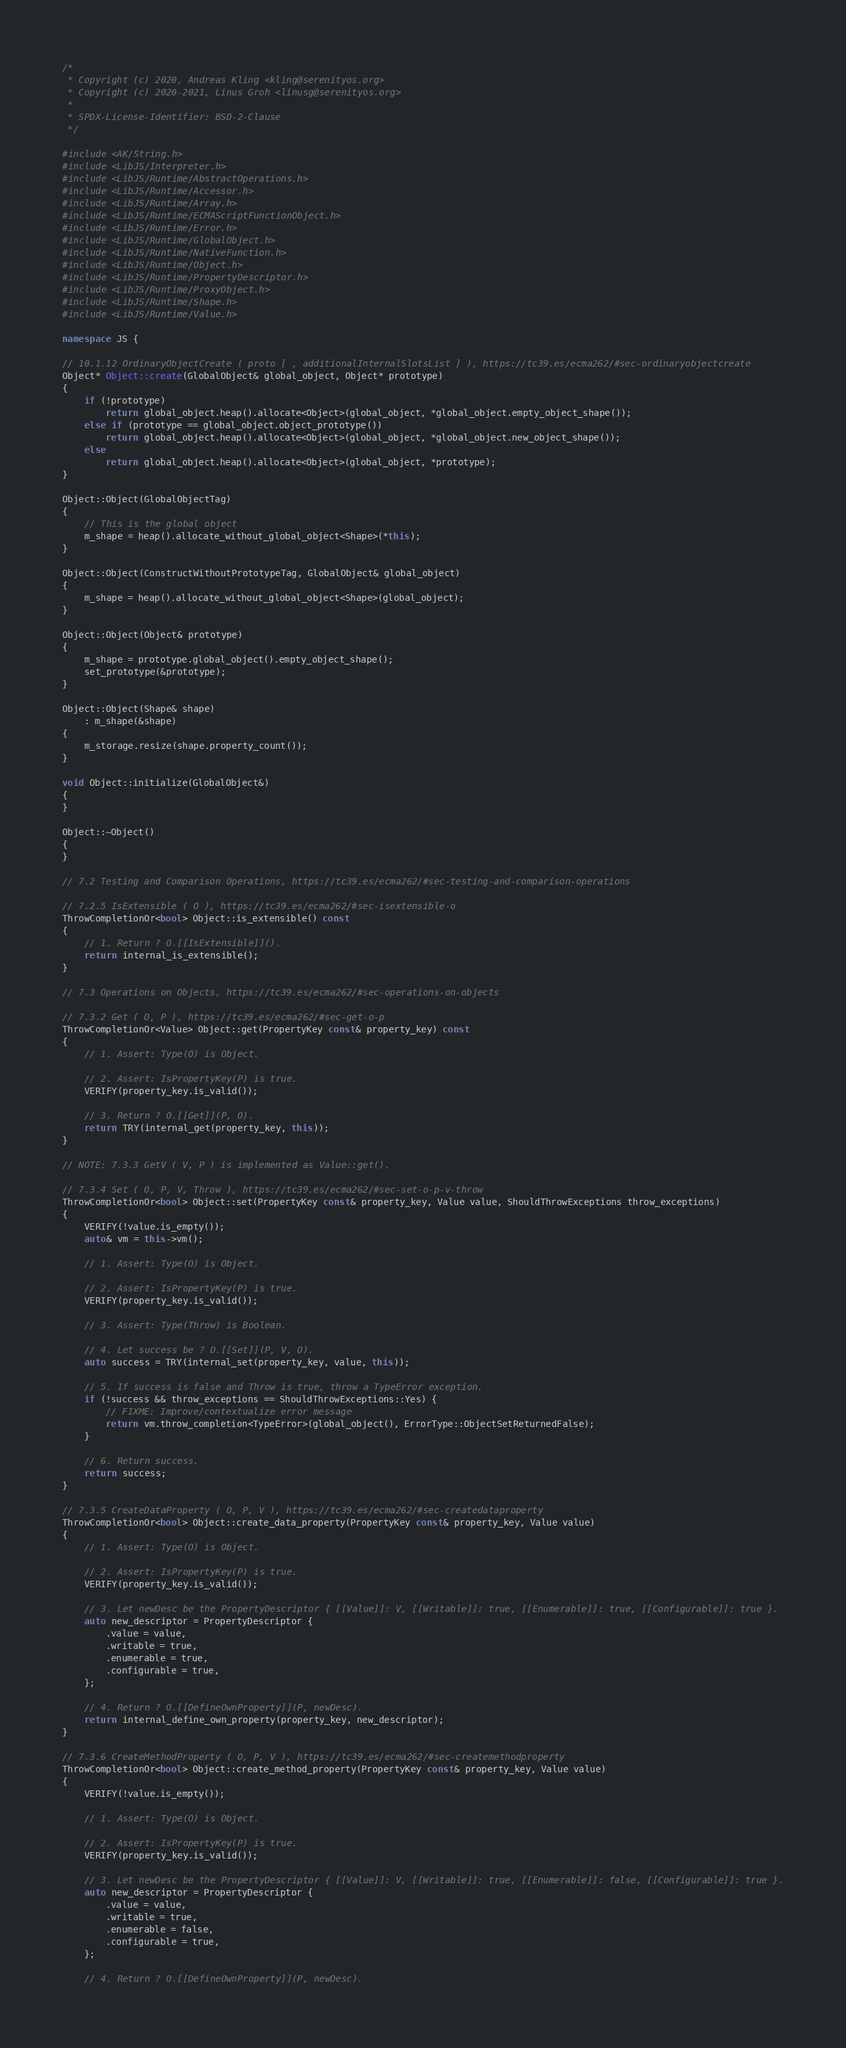Convert code to text. <code><loc_0><loc_0><loc_500><loc_500><_C++_>/*
 * Copyright (c) 2020, Andreas Kling <kling@serenityos.org>
 * Copyright (c) 2020-2021, Linus Groh <linusg@serenityos.org>
 *
 * SPDX-License-Identifier: BSD-2-Clause
 */

#include <AK/String.h>
#include <LibJS/Interpreter.h>
#include <LibJS/Runtime/AbstractOperations.h>
#include <LibJS/Runtime/Accessor.h>
#include <LibJS/Runtime/Array.h>
#include <LibJS/Runtime/ECMAScriptFunctionObject.h>
#include <LibJS/Runtime/Error.h>
#include <LibJS/Runtime/GlobalObject.h>
#include <LibJS/Runtime/NativeFunction.h>
#include <LibJS/Runtime/Object.h>
#include <LibJS/Runtime/PropertyDescriptor.h>
#include <LibJS/Runtime/ProxyObject.h>
#include <LibJS/Runtime/Shape.h>
#include <LibJS/Runtime/Value.h>

namespace JS {

// 10.1.12 OrdinaryObjectCreate ( proto [ , additionalInternalSlotsList ] ), https://tc39.es/ecma262/#sec-ordinaryobjectcreate
Object* Object::create(GlobalObject& global_object, Object* prototype)
{
    if (!prototype)
        return global_object.heap().allocate<Object>(global_object, *global_object.empty_object_shape());
    else if (prototype == global_object.object_prototype())
        return global_object.heap().allocate<Object>(global_object, *global_object.new_object_shape());
    else
        return global_object.heap().allocate<Object>(global_object, *prototype);
}

Object::Object(GlobalObjectTag)
{
    // This is the global object
    m_shape = heap().allocate_without_global_object<Shape>(*this);
}

Object::Object(ConstructWithoutPrototypeTag, GlobalObject& global_object)
{
    m_shape = heap().allocate_without_global_object<Shape>(global_object);
}

Object::Object(Object& prototype)
{
    m_shape = prototype.global_object().empty_object_shape();
    set_prototype(&prototype);
}

Object::Object(Shape& shape)
    : m_shape(&shape)
{
    m_storage.resize(shape.property_count());
}

void Object::initialize(GlobalObject&)
{
}

Object::~Object()
{
}

// 7.2 Testing and Comparison Operations, https://tc39.es/ecma262/#sec-testing-and-comparison-operations

// 7.2.5 IsExtensible ( O ), https://tc39.es/ecma262/#sec-isextensible-o
ThrowCompletionOr<bool> Object::is_extensible() const
{
    // 1. Return ? O.[[IsExtensible]]().
    return internal_is_extensible();
}

// 7.3 Operations on Objects, https://tc39.es/ecma262/#sec-operations-on-objects

// 7.3.2 Get ( O, P ), https://tc39.es/ecma262/#sec-get-o-p
ThrowCompletionOr<Value> Object::get(PropertyKey const& property_key) const
{
    // 1. Assert: Type(O) is Object.

    // 2. Assert: IsPropertyKey(P) is true.
    VERIFY(property_key.is_valid());

    // 3. Return ? O.[[Get]](P, O).
    return TRY(internal_get(property_key, this));
}

// NOTE: 7.3.3 GetV ( V, P ) is implemented as Value::get().

// 7.3.4 Set ( O, P, V, Throw ), https://tc39.es/ecma262/#sec-set-o-p-v-throw
ThrowCompletionOr<bool> Object::set(PropertyKey const& property_key, Value value, ShouldThrowExceptions throw_exceptions)
{
    VERIFY(!value.is_empty());
    auto& vm = this->vm();

    // 1. Assert: Type(O) is Object.

    // 2. Assert: IsPropertyKey(P) is true.
    VERIFY(property_key.is_valid());

    // 3. Assert: Type(Throw) is Boolean.

    // 4. Let success be ? O.[[Set]](P, V, O).
    auto success = TRY(internal_set(property_key, value, this));

    // 5. If success is false and Throw is true, throw a TypeError exception.
    if (!success && throw_exceptions == ShouldThrowExceptions::Yes) {
        // FIXME: Improve/contextualize error message
        return vm.throw_completion<TypeError>(global_object(), ErrorType::ObjectSetReturnedFalse);
    }

    // 6. Return success.
    return success;
}

// 7.3.5 CreateDataProperty ( O, P, V ), https://tc39.es/ecma262/#sec-createdataproperty
ThrowCompletionOr<bool> Object::create_data_property(PropertyKey const& property_key, Value value)
{
    // 1. Assert: Type(O) is Object.

    // 2. Assert: IsPropertyKey(P) is true.
    VERIFY(property_key.is_valid());

    // 3. Let newDesc be the PropertyDescriptor { [[Value]]: V, [[Writable]]: true, [[Enumerable]]: true, [[Configurable]]: true }.
    auto new_descriptor = PropertyDescriptor {
        .value = value,
        .writable = true,
        .enumerable = true,
        .configurable = true,
    };

    // 4. Return ? O.[[DefineOwnProperty]](P, newDesc).
    return internal_define_own_property(property_key, new_descriptor);
}

// 7.3.6 CreateMethodProperty ( O, P, V ), https://tc39.es/ecma262/#sec-createmethodproperty
ThrowCompletionOr<bool> Object::create_method_property(PropertyKey const& property_key, Value value)
{
    VERIFY(!value.is_empty());

    // 1. Assert: Type(O) is Object.

    // 2. Assert: IsPropertyKey(P) is true.
    VERIFY(property_key.is_valid());

    // 3. Let newDesc be the PropertyDescriptor { [[Value]]: V, [[Writable]]: true, [[Enumerable]]: false, [[Configurable]]: true }.
    auto new_descriptor = PropertyDescriptor {
        .value = value,
        .writable = true,
        .enumerable = false,
        .configurable = true,
    };

    // 4. Return ? O.[[DefineOwnProperty]](P, newDesc).</code> 